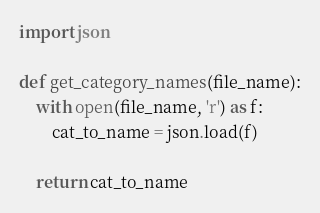Convert code to text. <code><loc_0><loc_0><loc_500><loc_500><_Python_>import json

def get_category_names(file_name):
    with open(file_name, 'r') as f:
        cat_to_name = json.load(f)
        
    return cat_to_name</code> 